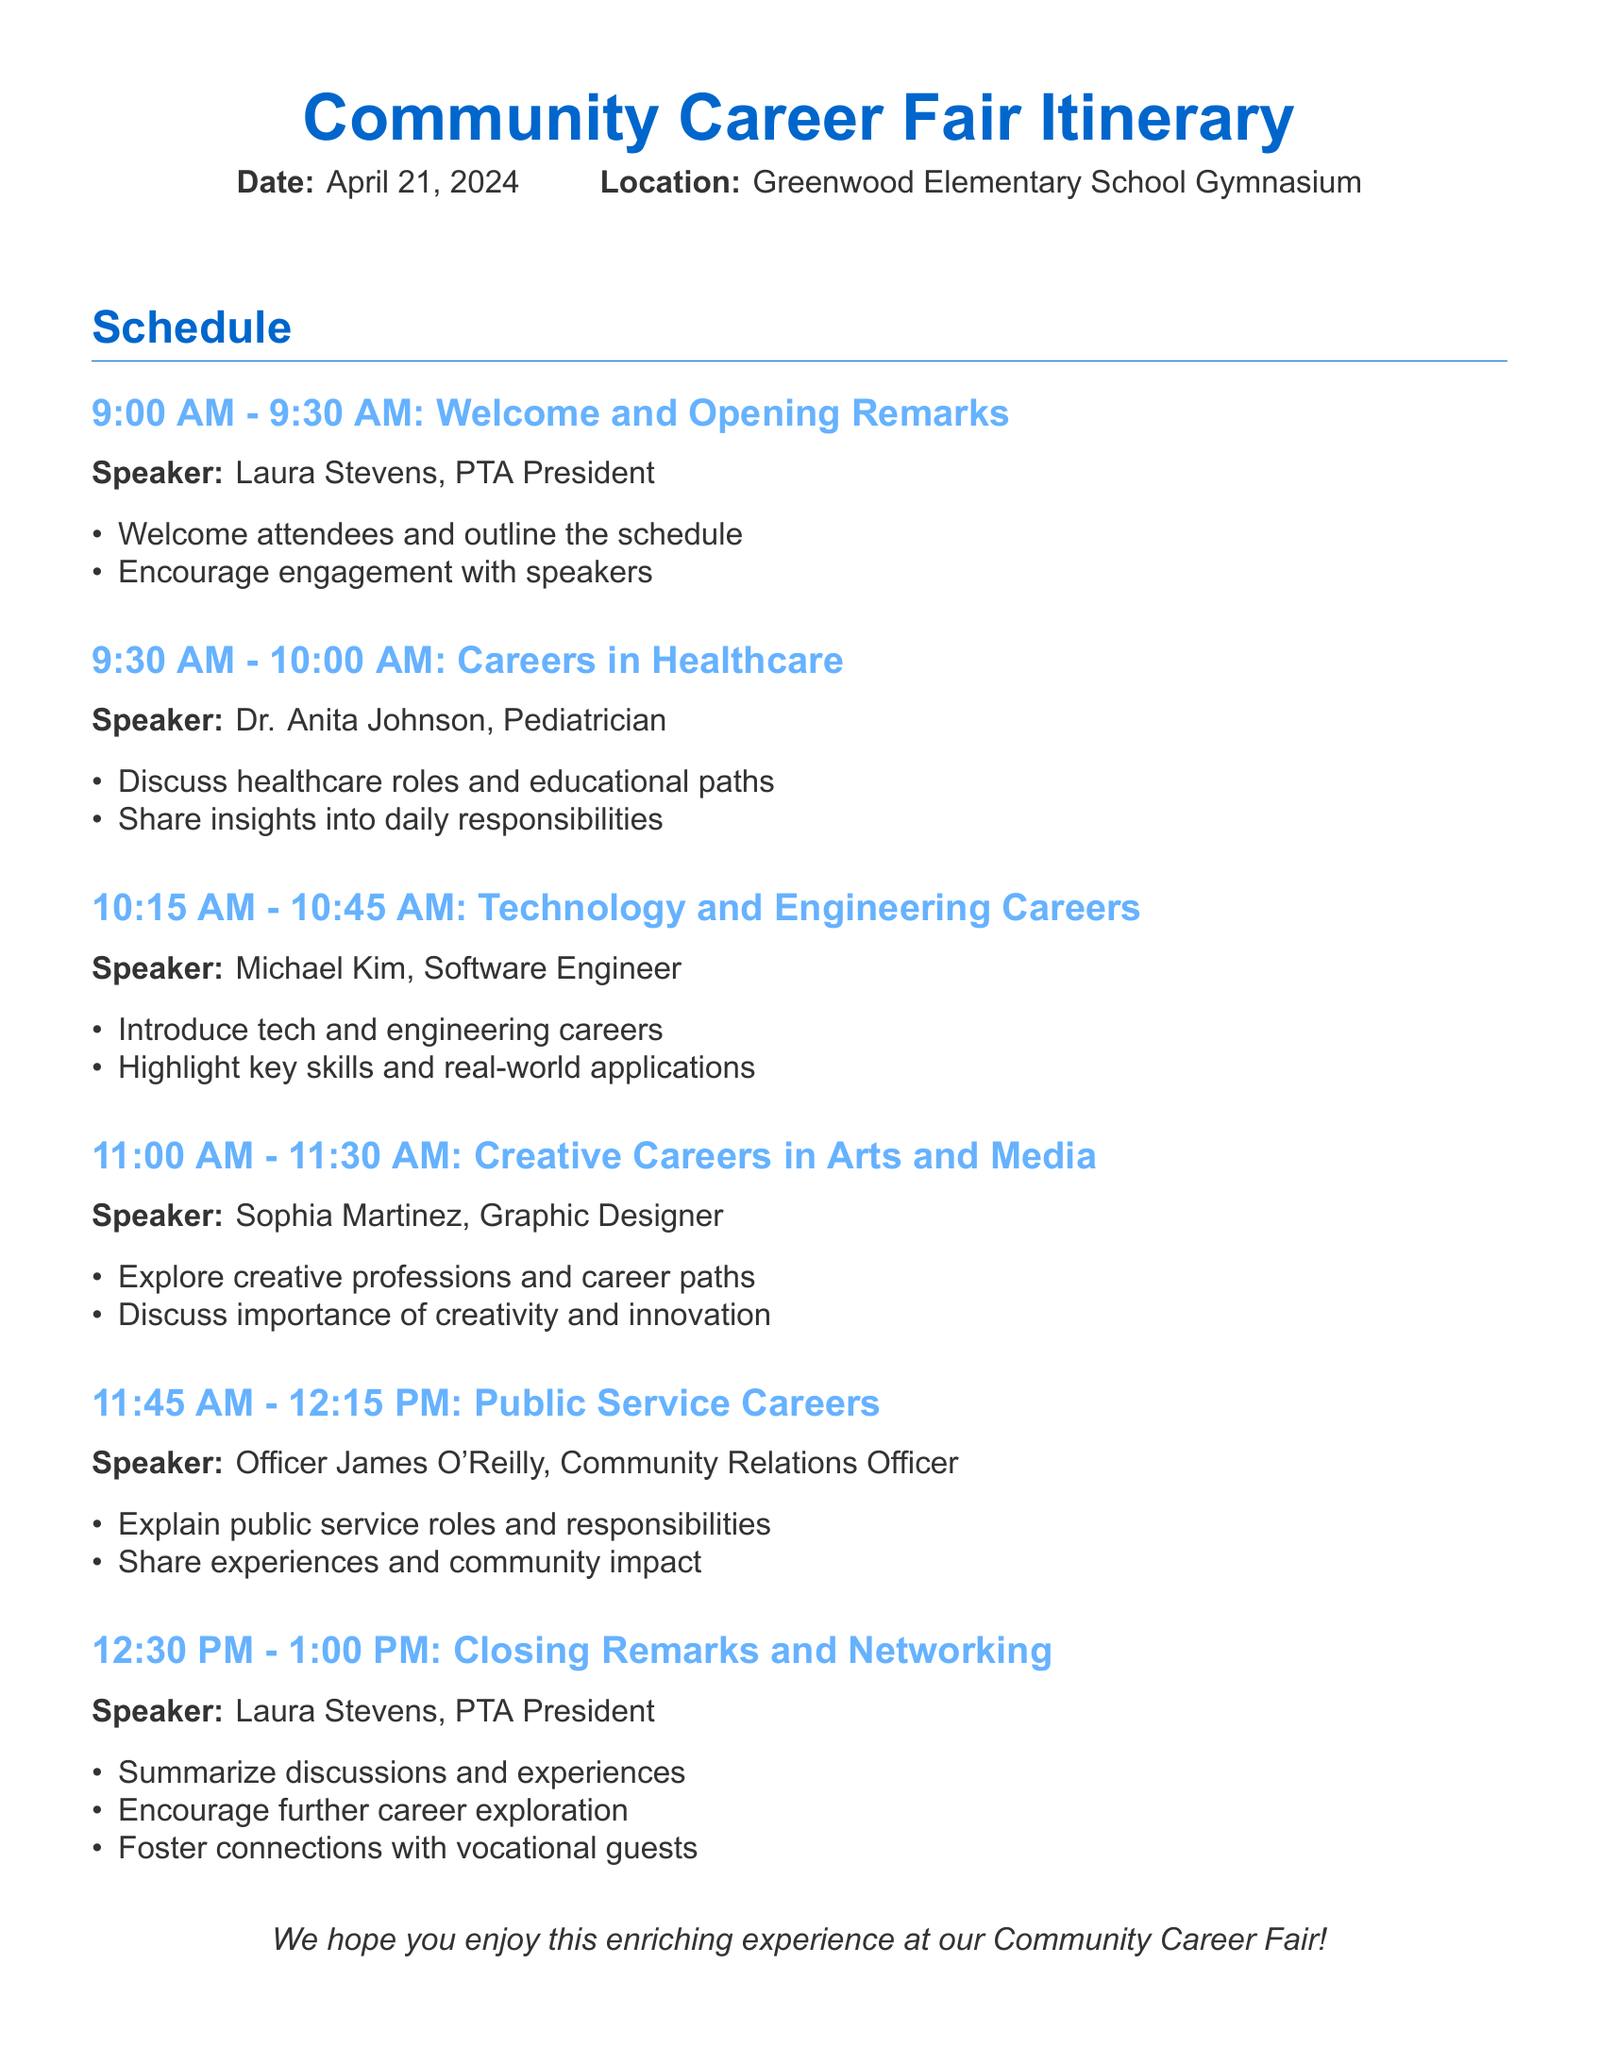What is the date of the Career Fair? The date of the Career Fair is explicitly stated in the document.
Answer: April 21, 2024 Who is the first speaker at the event? The first speaker's name and title are given in the schedule section.
Answer: Laura Stevens, PTA President What time does the presentation on Public Service Careers start? The schedule provides specific time slots for each presentation, including when the public service careers presentation begins.
Answer: 11:45 AM What career field does Officer James O'Reilly represent? The document specifies the career fields being discussed by each speaker.
Answer: Public Service What is the duration of the presentation on Technology and Engineering Careers? The schedule outlines the start and end times for each presentation to calculate durations.
Answer: 30 minutes How many presentations are scheduled before the closing remarks? By counting the number of presentations listed prior to the closing remarks in the itinerary, the answer can be determined.
Answer: 4 presentations What is one objective of Dr. Anita Johnson’s presentation? The document lists objectives for each speaker's presentation, which help to understand their focus.
Answer: Discuss healthcare roles and educational paths What is the last activity of the Career Fair? The itinerary outlines the final scheduled event at the end of the day.
Answer: Closing Remarks and Networking 